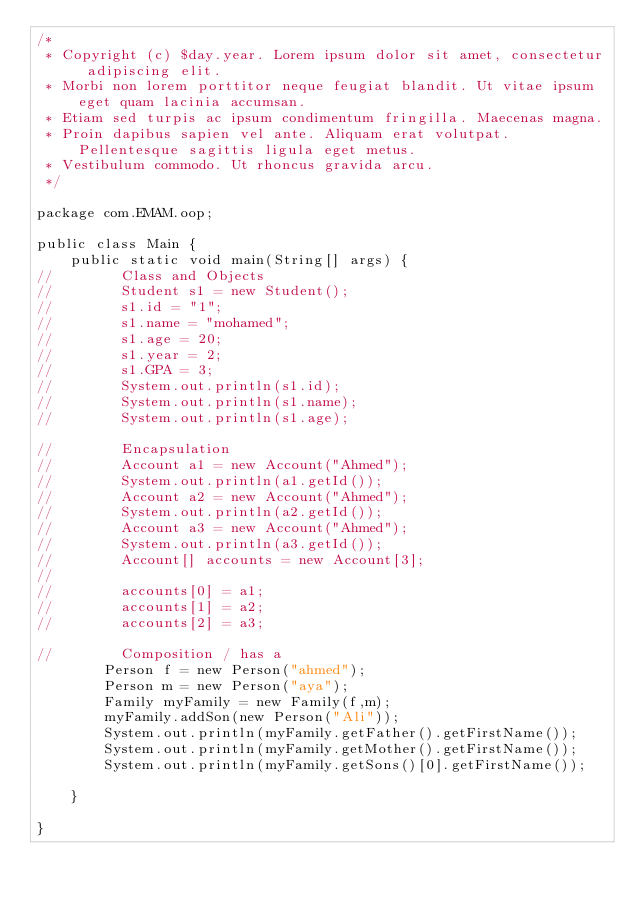<code> <loc_0><loc_0><loc_500><loc_500><_Java_>/*
 * Copyright (c) $day.year. Lorem ipsum dolor sit amet, consectetur adipiscing elit.
 * Morbi non lorem porttitor neque feugiat blandit. Ut vitae ipsum eget quam lacinia accumsan.
 * Etiam sed turpis ac ipsum condimentum fringilla. Maecenas magna.
 * Proin dapibus sapien vel ante. Aliquam erat volutpat. Pellentesque sagittis ligula eget metus.
 * Vestibulum commodo. Ut rhoncus gravida arcu.
 */

package com.EMAM.oop;

public class Main {
    public static void main(String[] args) {
//        Class and Objects
//        Student s1 = new Student();
//        s1.id = "1";
//        s1.name = "mohamed";
//        s1.age = 20;
//        s1.year = 2;
//        s1.GPA = 3;
//        System.out.println(s1.id);
//        System.out.println(s1.name);
//        System.out.println(s1.age);

//        Encapsulation
//        Account a1 = new Account("Ahmed");
//        System.out.println(a1.getId());
//        Account a2 = new Account("Ahmed");
//        System.out.println(a2.getId());
//        Account a3 = new Account("Ahmed");
//        System.out.println(a3.getId());
//        Account[] accounts = new Account[3];
//
//        accounts[0] = a1;
//        accounts[1] = a2;
//        accounts[2] = a3;

//        Composition / has a
        Person f = new Person("ahmed");
        Person m = new Person("aya");
        Family myFamily = new Family(f,m);
        myFamily.addSon(new Person("Ali"));
        System.out.println(myFamily.getFather().getFirstName());
        System.out.println(myFamily.getMother().getFirstName());
        System.out.println(myFamily.getSons()[0].getFirstName());

    }

}
</code> 